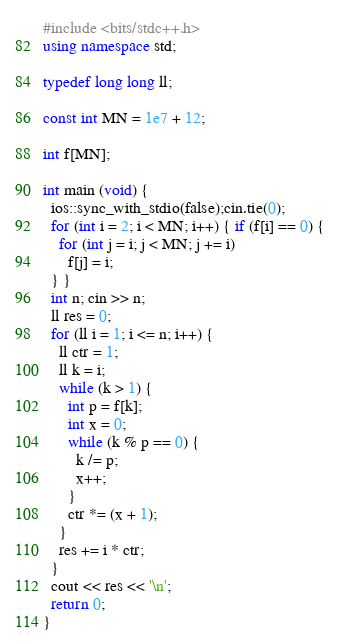<code> <loc_0><loc_0><loc_500><loc_500><_C++_>#include <bits/stdc++.h>
using namespace std;

typedef long long ll;

const int MN = 1e7 + 12;

int f[MN];

int main (void) {
  ios::sync_with_stdio(false);cin.tie(0);
  for (int i = 2; i < MN; i++) { if (f[i] == 0) {
    for (int j = i; j < MN; j += i)
      f[j] = i;
  } }
  int n; cin >> n;
  ll res = 0;
  for (ll i = 1; i <= n; i++) {
    ll ctr = 1;
    ll k = i;
    while (k > 1) {
      int p = f[k];
      int x = 0;
      while (k % p == 0) {
        k /= p;
        x++;
      }
      ctr *= (x + 1);
    }
    res += i * ctr;
  }
  cout << res << '\n';
  return 0;
}

</code> 